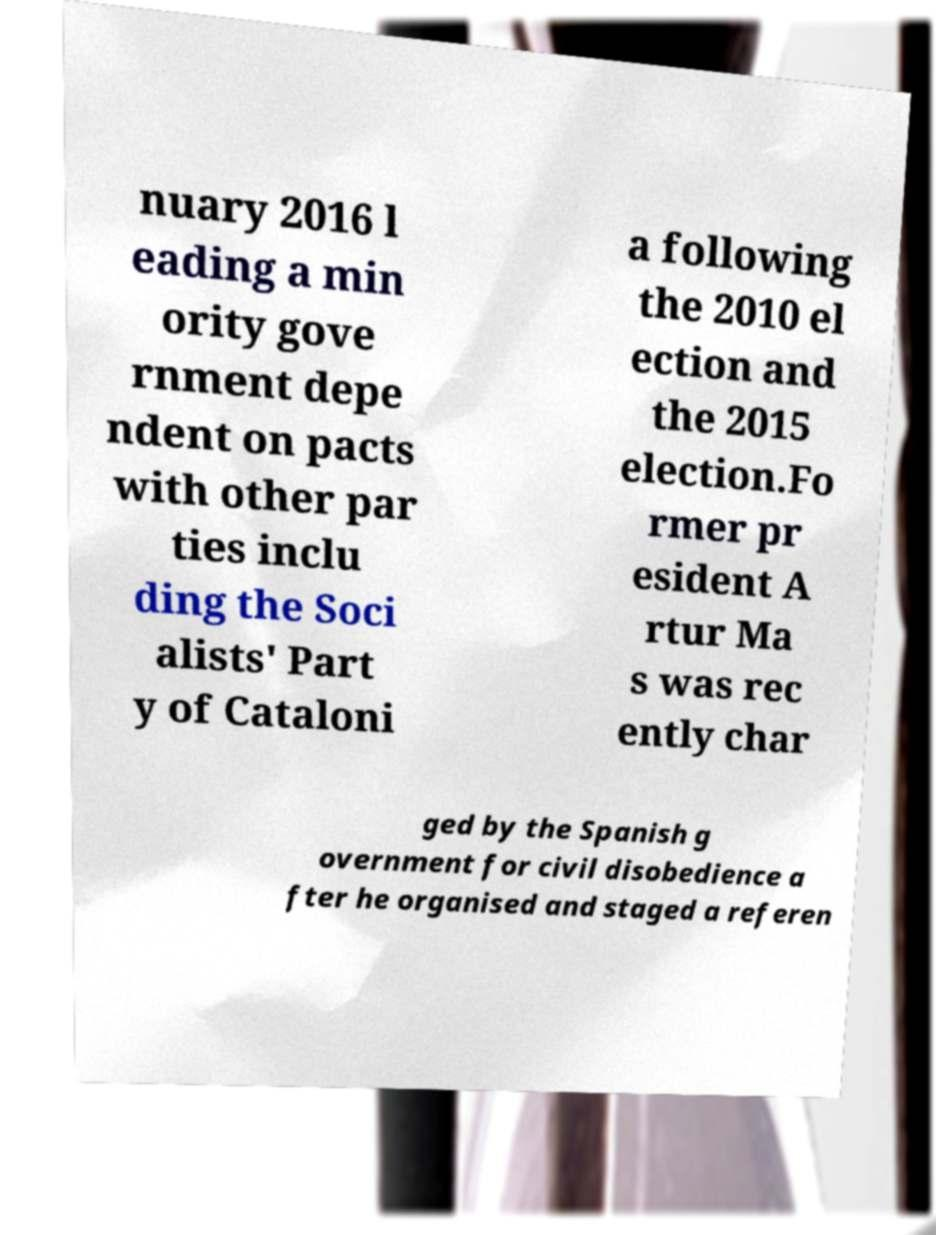Can you read and provide the text displayed in the image?This photo seems to have some interesting text. Can you extract and type it out for me? nuary 2016 l eading a min ority gove rnment depe ndent on pacts with other par ties inclu ding the Soci alists' Part y of Cataloni a following the 2010 el ection and the 2015 election.Fo rmer pr esident A rtur Ma s was rec ently char ged by the Spanish g overnment for civil disobedience a fter he organised and staged a referen 